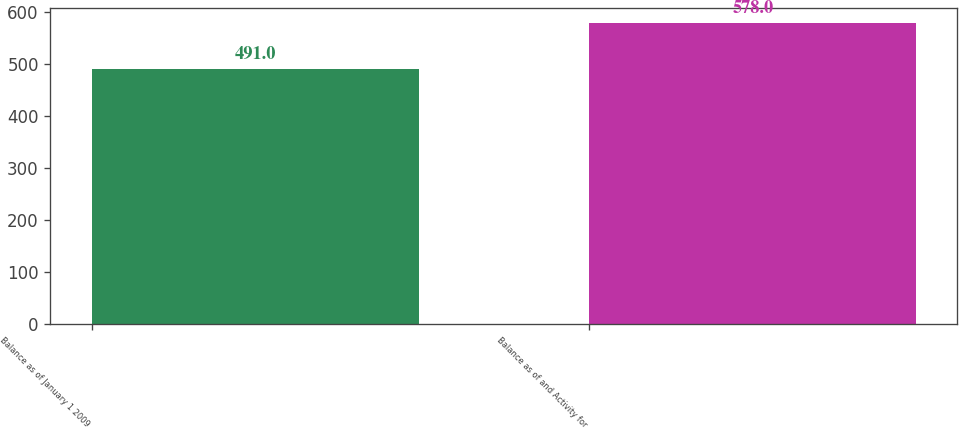Convert chart. <chart><loc_0><loc_0><loc_500><loc_500><bar_chart><fcel>Balance as of January 1 2009<fcel>Balance as of and Activity for<nl><fcel>491<fcel>578<nl></chart> 